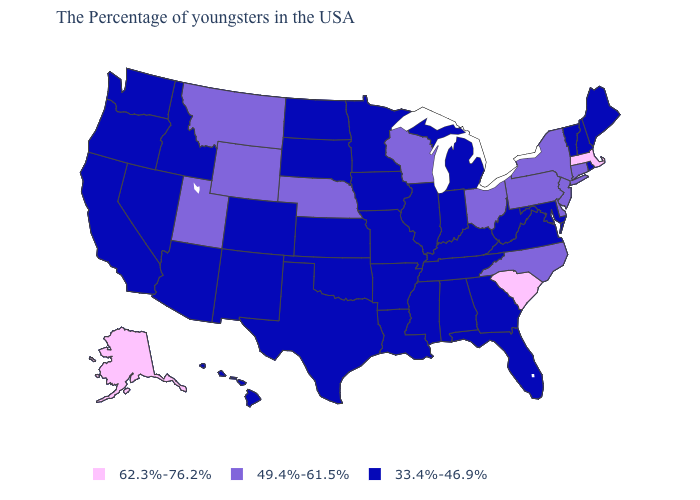Name the states that have a value in the range 62.3%-76.2%?
Be succinct. Massachusetts, South Carolina, Alaska. What is the lowest value in states that border Connecticut?
Give a very brief answer. 33.4%-46.9%. What is the value of Wyoming?
Concise answer only. 49.4%-61.5%. What is the value of Alabama?
Concise answer only. 33.4%-46.9%. Name the states that have a value in the range 62.3%-76.2%?
Write a very short answer. Massachusetts, South Carolina, Alaska. What is the highest value in the West ?
Short answer required. 62.3%-76.2%. What is the value of Pennsylvania?
Concise answer only. 49.4%-61.5%. Name the states that have a value in the range 49.4%-61.5%?
Short answer required. Connecticut, New York, New Jersey, Delaware, Pennsylvania, North Carolina, Ohio, Wisconsin, Nebraska, Wyoming, Utah, Montana. Name the states that have a value in the range 49.4%-61.5%?
Concise answer only. Connecticut, New York, New Jersey, Delaware, Pennsylvania, North Carolina, Ohio, Wisconsin, Nebraska, Wyoming, Utah, Montana. Name the states that have a value in the range 33.4%-46.9%?
Write a very short answer. Maine, Rhode Island, New Hampshire, Vermont, Maryland, Virginia, West Virginia, Florida, Georgia, Michigan, Kentucky, Indiana, Alabama, Tennessee, Illinois, Mississippi, Louisiana, Missouri, Arkansas, Minnesota, Iowa, Kansas, Oklahoma, Texas, South Dakota, North Dakota, Colorado, New Mexico, Arizona, Idaho, Nevada, California, Washington, Oregon, Hawaii. What is the value of Maryland?
Concise answer only. 33.4%-46.9%. Name the states that have a value in the range 49.4%-61.5%?
Answer briefly. Connecticut, New York, New Jersey, Delaware, Pennsylvania, North Carolina, Ohio, Wisconsin, Nebraska, Wyoming, Utah, Montana. Name the states that have a value in the range 33.4%-46.9%?
Concise answer only. Maine, Rhode Island, New Hampshire, Vermont, Maryland, Virginia, West Virginia, Florida, Georgia, Michigan, Kentucky, Indiana, Alabama, Tennessee, Illinois, Mississippi, Louisiana, Missouri, Arkansas, Minnesota, Iowa, Kansas, Oklahoma, Texas, South Dakota, North Dakota, Colorado, New Mexico, Arizona, Idaho, Nevada, California, Washington, Oregon, Hawaii. Which states have the lowest value in the West?
Write a very short answer. Colorado, New Mexico, Arizona, Idaho, Nevada, California, Washington, Oregon, Hawaii. Does Wisconsin have the lowest value in the MidWest?
Answer briefly. No. 